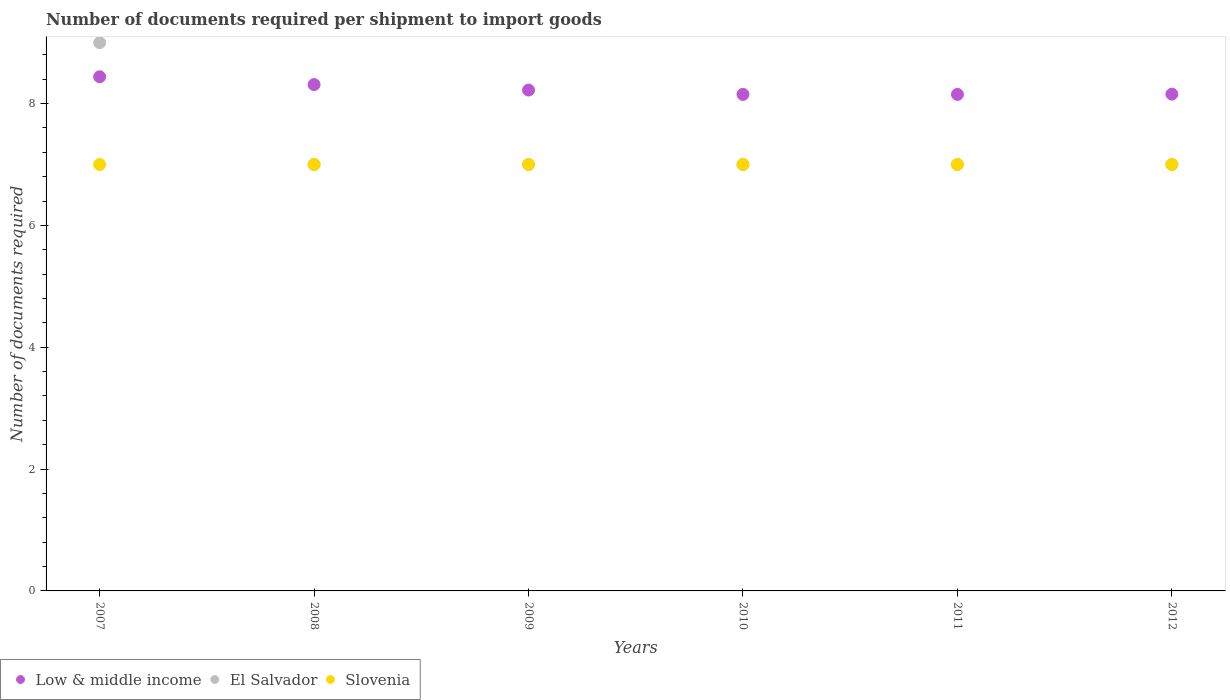What is the number of documents required per shipment to import goods in Slovenia in 2011?
Make the answer very short. 7. Across all years, what is the maximum number of documents required per shipment to import goods in Slovenia?
Your answer should be very brief. 7. Across all years, what is the minimum number of documents required per shipment to import goods in Slovenia?
Make the answer very short. 7. In which year was the number of documents required per shipment to import goods in El Salvador minimum?
Your answer should be compact. 2008. What is the total number of documents required per shipment to import goods in Slovenia in the graph?
Offer a terse response. 42. What is the difference between the number of documents required per shipment to import goods in Low & middle income in 2009 and that in 2012?
Your answer should be very brief. 0.07. What is the difference between the number of documents required per shipment to import goods in Slovenia in 2011 and the number of documents required per shipment to import goods in Low & middle income in 2009?
Offer a terse response. -1.22. What is the average number of documents required per shipment to import goods in Slovenia per year?
Provide a short and direct response. 7. In the year 2011, what is the difference between the number of documents required per shipment to import goods in Slovenia and number of documents required per shipment to import goods in Low & middle income?
Your answer should be compact. -1.15. In how many years, is the number of documents required per shipment to import goods in Slovenia greater than 4?
Your answer should be compact. 6. What is the ratio of the number of documents required per shipment to import goods in El Salvador in 2008 to that in 2012?
Give a very brief answer. 1. Is the difference between the number of documents required per shipment to import goods in Slovenia in 2011 and 2012 greater than the difference between the number of documents required per shipment to import goods in Low & middle income in 2011 and 2012?
Your answer should be compact. Yes. In how many years, is the number of documents required per shipment to import goods in Low & middle income greater than the average number of documents required per shipment to import goods in Low & middle income taken over all years?
Offer a very short reply. 2. Is the sum of the number of documents required per shipment to import goods in Slovenia in 2010 and 2011 greater than the maximum number of documents required per shipment to import goods in Low & middle income across all years?
Your response must be concise. Yes. Is it the case that in every year, the sum of the number of documents required per shipment to import goods in Low & middle income and number of documents required per shipment to import goods in Slovenia  is greater than the number of documents required per shipment to import goods in El Salvador?
Keep it short and to the point. Yes. Does the number of documents required per shipment to import goods in El Salvador monotonically increase over the years?
Ensure brevity in your answer.  No. How many years are there in the graph?
Provide a succinct answer. 6. Does the graph contain grids?
Give a very brief answer. No. Where does the legend appear in the graph?
Make the answer very short. Bottom left. How many legend labels are there?
Keep it short and to the point. 3. What is the title of the graph?
Ensure brevity in your answer.  Number of documents required per shipment to import goods. What is the label or title of the Y-axis?
Offer a very short reply. Number of documents required. What is the Number of documents required of Low & middle income in 2007?
Offer a terse response. 8.44. What is the Number of documents required in El Salvador in 2007?
Ensure brevity in your answer.  9. What is the Number of documents required of Slovenia in 2007?
Your answer should be very brief. 7. What is the Number of documents required in Low & middle income in 2008?
Provide a succinct answer. 8.31. What is the Number of documents required in El Salvador in 2008?
Keep it short and to the point. 7. What is the Number of documents required in Low & middle income in 2009?
Your answer should be compact. 8.22. What is the Number of documents required of Slovenia in 2009?
Give a very brief answer. 7. What is the Number of documents required of Low & middle income in 2010?
Keep it short and to the point. 8.15. What is the Number of documents required in El Salvador in 2010?
Ensure brevity in your answer.  7. What is the Number of documents required in Slovenia in 2010?
Your answer should be very brief. 7. What is the Number of documents required of Low & middle income in 2011?
Ensure brevity in your answer.  8.15. What is the Number of documents required of Low & middle income in 2012?
Ensure brevity in your answer.  8.16. Across all years, what is the maximum Number of documents required in Low & middle income?
Your answer should be compact. 8.44. Across all years, what is the maximum Number of documents required in Slovenia?
Your answer should be very brief. 7. Across all years, what is the minimum Number of documents required in Low & middle income?
Provide a short and direct response. 8.15. Across all years, what is the minimum Number of documents required of El Salvador?
Ensure brevity in your answer.  7. Across all years, what is the minimum Number of documents required of Slovenia?
Give a very brief answer. 7. What is the total Number of documents required of Low & middle income in the graph?
Provide a short and direct response. 49.43. What is the difference between the Number of documents required of Low & middle income in 2007 and that in 2008?
Ensure brevity in your answer.  0.13. What is the difference between the Number of documents required in El Salvador in 2007 and that in 2008?
Ensure brevity in your answer.  2. What is the difference between the Number of documents required in Slovenia in 2007 and that in 2008?
Offer a terse response. 0. What is the difference between the Number of documents required in Low & middle income in 2007 and that in 2009?
Provide a succinct answer. 0.22. What is the difference between the Number of documents required of Low & middle income in 2007 and that in 2010?
Make the answer very short. 0.29. What is the difference between the Number of documents required of El Salvador in 2007 and that in 2010?
Your response must be concise. 2. What is the difference between the Number of documents required in Low & middle income in 2007 and that in 2011?
Make the answer very short. 0.29. What is the difference between the Number of documents required of Slovenia in 2007 and that in 2011?
Provide a succinct answer. 0. What is the difference between the Number of documents required in Low & middle income in 2007 and that in 2012?
Your response must be concise. 0.28. What is the difference between the Number of documents required of El Salvador in 2007 and that in 2012?
Provide a succinct answer. 2. What is the difference between the Number of documents required in Low & middle income in 2008 and that in 2009?
Offer a terse response. 0.09. What is the difference between the Number of documents required in El Salvador in 2008 and that in 2009?
Your answer should be very brief. 0. What is the difference between the Number of documents required of Low & middle income in 2008 and that in 2010?
Your answer should be compact. 0.16. What is the difference between the Number of documents required of El Salvador in 2008 and that in 2010?
Your answer should be very brief. 0. What is the difference between the Number of documents required of Low & middle income in 2008 and that in 2011?
Your answer should be compact. 0.16. What is the difference between the Number of documents required of El Salvador in 2008 and that in 2011?
Your answer should be compact. 0. What is the difference between the Number of documents required in Low & middle income in 2008 and that in 2012?
Provide a short and direct response. 0.16. What is the difference between the Number of documents required of Slovenia in 2008 and that in 2012?
Ensure brevity in your answer.  0. What is the difference between the Number of documents required in Low & middle income in 2009 and that in 2010?
Make the answer very short. 0.07. What is the difference between the Number of documents required of El Salvador in 2009 and that in 2010?
Make the answer very short. 0. What is the difference between the Number of documents required of Low & middle income in 2009 and that in 2011?
Offer a very short reply. 0.07. What is the difference between the Number of documents required in Slovenia in 2009 and that in 2011?
Your answer should be compact. 0. What is the difference between the Number of documents required in Low & middle income in 2009 and that in 2012?
Give a very brief answer. 0.07. What is the difference between the Number of documents required in El Salvador in 2009 and that in 2012?
Your answer should be compact. 0. What is the difference between the Number of documents required of Slovenia in 2009 and that in 2012?
Provide a succinct answer. 0. What is the difference between the Number of documents required of El Salvador in 2010 and that in 2011?
Ensure brevity in your answer.  0. What is the difference between the Number of documents required of Low & middle income in 2010 and that in 2012?
Provide a succinct answer. -0. What is the difference between the Number of documents required of Low & middle income in 2011 and that in 2012?
Make the answer very short. -0. What is the difference between the Number of documents required of Low & middle income in 2007 and the Number of documents required of El Salvador in 2008?
Your answer should be compact. 1.44. What is the difference between the Number of documents required of Low & middle income in 2007 and the Number of documents required of Slovenia in 2008?
Make the answer very short. 1.44. What is the difference between the Number of documents required in Low & middle income in 2007 and the Number of documents required in El Salvador in 2009?
Your answer should be compact. 1.44. What is the difference between the Number of documents required of Low & middle income in 2007 and the Number of documents required of Slovenia in 2009?
Ensure brevity in your answer.  1.44. What is the difference between the Number of documents required in Low & middle income in 2007 and the Number of documents required in El Salvador in 2010?
Give a very brief answer. 1.44. What is the difference between the Number of documents required in Low & middle income in 2007 and the Number of documents required in Slovenia in 2010?
Ensure brevity in your answer.  1.44. What is the difference between the Number of documents required in El Salvador in 2007 and the Number of documents required in Slovenia in 2010?
Keep it short and to the point. 2. What is the difference between the Number of documents required of Low & middle income in 2007 and the Number of documents required of El Salvador in 2011?
Make the answer very short. 1.44. What is the difference between the Number of documents required in Low & middle income in 2007 and the Number of documents required in Slovenia in 2011?
Your response must be concise. 1.44. What is the difference between the Number of documents required in Low & middle income in 2007 and the Number of documents required in El Salvador in 2012?
Provide a succinct answer. 1.44. What is the difference between the Number of documents required of Low & middle income in 2007 and the Number of documents required of Slovenia in 2012?
Make the answer very short. 1.44. What is the difference between the Number of documents required in El Salvador in 2007 and the Number of documents required in Slovenia in 2012?
Offer a terse response. 2. What is the difference between the Number of documents required in Low & middle income in 2008 and the Number of documents required in El Salvador in 2009?
Offer a terse response. 1.31. What is the difference between the Number of documents required in Low & middle income in 2008 and the Number of documents required in Slovenia in 2009?
Make the answer very short. 1.31. What is the difference between the Number of documents required in El Salvador in 2008 and the Number of documents required in Slovenia in 2009?
Ensure brevity in your answer.  0. What is the difference between the Number of documents required in Low & middle income in 2008 and the Number of documents required in El Salvador in 2010?
Provide a short and direct response. 1.31. What is the difference between the Number of documents required in Low & middle income in 2008 and the Number of documents required in Slovenia in 2010?
Your answer should be very brief. 1.31. What is the difference between the Number of documents required in Low & middle income in 2008 and the Number of documents required in El Salvador in 2011?
Give a very brief answer. 1.31. What is the difference between the Number of documents required of Low & middle income in 2008 and the Number of documents required of Slovenia in 2011?
Your response must be concise. 1.31. What is the difference between the Number of documents required of Low & middle income in 2008 and the Number of documents required of El Salvador in 2012?
Keep it short and to the point. 1.31. What is the difference between the Number of documents required in Low & middle income in 2008 and the Number of documents required in Slovenia in 2012?
Ensure brevity in your answer.  1.31. What is the difference between the Number of documents required in Low & middle income in 2009 and the Number of documents required in El Salvador in 2010?
Provide a succinct answer. 1.22. What is the difference between the Number of documents required of Low & middle income in 2009 and the Number of documents required of Slovenia in 2010?
Keep it short and to the point. 1.22. What is the difference between the Number of documents required in Low & middle income in 2009 and the Number of documents required in El Salvador in 2011?
Ensure brevity in your answer.  1.22. What is the difference between the Number of documents required in Low & middle income in 2009 and the Number of documents required in Slovenia in 2011?
Your response must be concise. 1.22. What is the difference between the Number of documents required of El Salvador in 2009 and the Number of documents required of Slovenia in 2011?
Offer a terse response. 0. What is the difference between the Number of documents required of Low & middle income in 2009 and the Number of documents required of El Salvador in 2012?
Provide a succinct answer. 1.22. What is the difference between the Number of documents required of Low & middle income in 2009 and the Number of documents required of Slovenia in 2012?
Keep it short and to the point. 1.22. What is the difference between the Number of documents required in Low & middle income in 2010 and the Number of documents required in El Salvador in 2011?
Provide a short and direct response. 1.15. What is the difference between the Number of documents required of Low & middle income in 2010 and the Number of documents required of Slovenia in 2011?
Offer a terse response. 1.15. What is the difference between the Number of documents required of El Salvador in 2010 and the Number of documents required of Slovenia in 2011?
Offer a terse response. 0. What is the difference between the Number of documents required in Low & middle income in 2010 and the Number of documents required in El Salvador in 2012?
Your answer should be compact. 1.15. What is the difference between the Number of documents required of Low & middle income in 2010 and the Number of documents required of Slovenia in 2012?
Your answer should be very brief. 1.15. What is the difference between the Number of documents required in Low & middle income in 2011 and the Number of documents required in El Salvador in 2012?
Offer a very short reply. 1.15. What is the difference between the Number of documents required in Low & middle income in 2011 and the Number of documents required in Slovenia in 2012?
Make the answer very short. 1.15. What is the difference between the Number of documents required of El Salvador in 2011 and the Number of documents required of Slovenia in 2012?
Your answer should be very brief. 0. What is the average Number of documents required of Low & middle income per year?
Ensure brevity in your answer.  8.24. What is the average Number of documents required of El Salvador per year?
Offer a terse response. 7.33. What is the average Number of documents required in Slovenia per year?
Provide a short and direct response. 7. In the year 2007, what is the difference between the Number of documents required in Low & middle income and Number of documents required in El Salvador?
Your answer should be compact. -0.56. In the year 2007, what is the difference between the Number of documents required of Low & middle income and Number of documents required of Slovenia?
Your answer should be compact. 1.44. In the year 2008, what is the difference between the Number of documents required in Low & middle income and Number of documents required in El Salvador?
Your response must be concise. 1.31. In the year 2008, what is the difference between the Number of documents required of Low & middle income and Number of documents required of Slovenia?
Ensure brevity in your answer.  1.31. In the year 2009, what is the difference between the Number of documents required of Low & middle income and Number of documents required of El Salvador?
Give a very brief answer. 1.22. In the year 2009, what is the difference between the Number of documents required of Low & middle income and Number of documents required of Slovenia?
Give a very brief answer. 1.22. In the year 2009, what is the difference between the Number of documents required of El Salvador and Number of documents required of Slovenia?
Give a very brief answer. 0. In the year 2010, what is the difference between the Number of documents required in Low & middle income and Number of documents required in El Salvador?
Offer a very short reply. 1.15. In the year 2010, what is the difference between the Number of documents required in Low & middle income and Number of documents required in Slovenia?
Give a very brief answer. 1.15. In the year 2010, what is the difference between the Number of documents required in El Salvador and Number of documents required in Slovenia?
Give a very brief answer. 0. In the year 2011, what is the difference between the Number of documents required of Low & middle income and Number of documents required of El Salvador?
Ensure brevity in your answer.  1.15. In the year 2011, what is the difference between the Number of documents required of Low & middle income and Number of documents required of Slovenia?
Offer a terse response. 1.15. In the year 2011, what is the difference between the Number of documents required of El Salvador and Number of documents required of Slovenia?
Offer a terse response. 0. In the year 2012, what is the difference between the Number of documents required in Low & middle income and Number of documents required in El Salvador?
Ensure brevity in your answer.  1.16. In the year 2012, what is the difference between the Number of documents required of Low & middle income and Number of documents required of Slovenia?
Give a very brief answer. 1.16. What is the ratio of the Number of documents required in Low & middle income in 2007 to that in 2008?
Offer a terse response. 1.02. What is the ratio of the Number of documents required in El Salvador in 2007 to that in 2008?
Make the answer very short. 1.29. What is the ratio of the Number of documents required in Low & middle income in 2007 to that in 2009?
Ensure brevity in your answer.  1.03. What is the ratio of the Number of documents required in Slovenia in 2007 to that in 2009?
Ensure brevity in your answer.  1. What is the ratio of the Number of documents required of Low & middle income in 2007 to that in 2010?
Keep it short and to the point. 1.04. What is the ratio of the Number of documents required of El Salvador in 2007 to that in 2010?
Make the answer very short. 1.29. What is the ratio of the Number of documents required of Slovenia in 2007 to that in 2010?
Offer a very short reply. 1. What is the ratio of the Number of documents required in Low & middle income in 2007 to that in 2011?
Your answer should be very brief. 1.04. What is the ratio of the Number of documents required of Low & middle income in 2007 to that in 2012?
Provide a succinct answer. 1.03. What is the ratio of the Number of documents required in El Salvador in 2007 to that in 2012?
Make the answer very short. 1.29. What is the ratio of the Number of documents required in Slovenia in 2007 to that in 2012?
Make the answer very short. 1. What is the ratio of the Number of documents required of Low & middle income in 2008 to that in 2009?
Offer a very short reply. 1.01. What is the ratio of the Number of documents required in Slovenia in 2008 to that in 2009?
Offer a terse response. 1. What is the ratio of the Number of documents required of Low & middle income in 2008 to that in 2010?
Provide a short and direct response. 1.02. What is the ratio of the Number of documents required of Slovenia in 2008 to that in 2010?
Offer a terse response. 1. What is the ratio of the Number of documents required of Low & middle income in 2008 to that in 2011?
Your answer should be very brief. 1.02. What is the ratio of the Number of documents required of El Salvador in 2008 to that in 2011?
Make the answer very short. 1. What is the ratio of the Number of documents required of Low & middle income in 2008 to that in 2012?
Make the answer very short. 1.02. What is the ratio of the Number of documents required in Slovenia in 2008 to that in 2012?
Make the answer very short. 1. What is the ratio of the Number of documents required of Low & middle income in 2009 to that in 2010?
Your answer should be very brief. 1.01. What is the ratio of the Number of documents required of Slovenia in 2009 to that in 2010?
Provide a short and direct response. 1. What is the ratio of the Number of documents required of Low & middle income in 2009 to that in 2011?
Provide a short and direct response. 1.01. What is the ratio of the Number of documents required of El Salvador in 2009 to that in 2011?
Your response must be concise. 1. What is the ratio of the Number of documents required in Slovenia in 2009 to that in 2011?
Make the answer very short. 1. What is the ratio of the Number of documents required in Low & middle income in 2009 to that in 2012?
Offer a very short reply. 1.01. What is the ratio of the Number of documents required of Slovenia in 2009 to that in 2012?
Your answer should be very brief. 1. What is the ratio of the Number of documents required in Slovenia in 2010 to that in 2012?
Your answer should be very brief. 1. What is the ratio of the Number of documents required of El Salvador in 2011 to that in 2012?
Your answer should be compact. 1. What is the ratio of the Number of documents required in Slovenia in 2011 to that in 2012?
Keep it short and to the point. 1. What is the difference between the highest and the second highest Number of documents required in Low & middle income?
Provide a succinct answer. 0.13. What is the difference between the highest and the lowest Number of documents required in Low & middle income?
Give a very brief answer. 0.29. What is the difference between the highest and the lowest Number of documents required in El Salvador?
Your answer should be very brief. 2. 